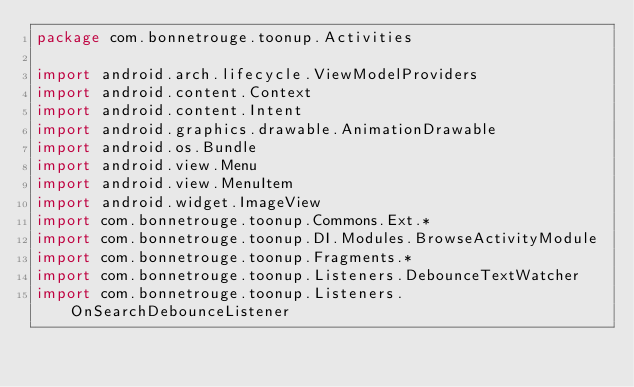Convert code to text. <code><loc_0><loc_0><loc_500><loc_500><_Kotlin_>package com.bonnetrouge.toonup.Activities

import android.arch.lifecycle.ViewModelProviders
import android.content.Context
import android.content.Intent
import android.graphics.drawable.AnimationDrawable
import android.os.Bundle
import android.view.Menu
import android.view.MenuItem
import android.widget.ImageView
import com.bonnetrouge.toonup.Commons.Ext.*
import com.bonnetrouge.toonup.DI.Modules.BrowseActivityModule
import com.bonnetrouge.toonup.Fragments.*
import com.bonnetrouge.toonup.Listeners.DebounceTextWatcher
import com.bonnetrouge.toonup.Listeners.OnSearchDebounceListener</code> 